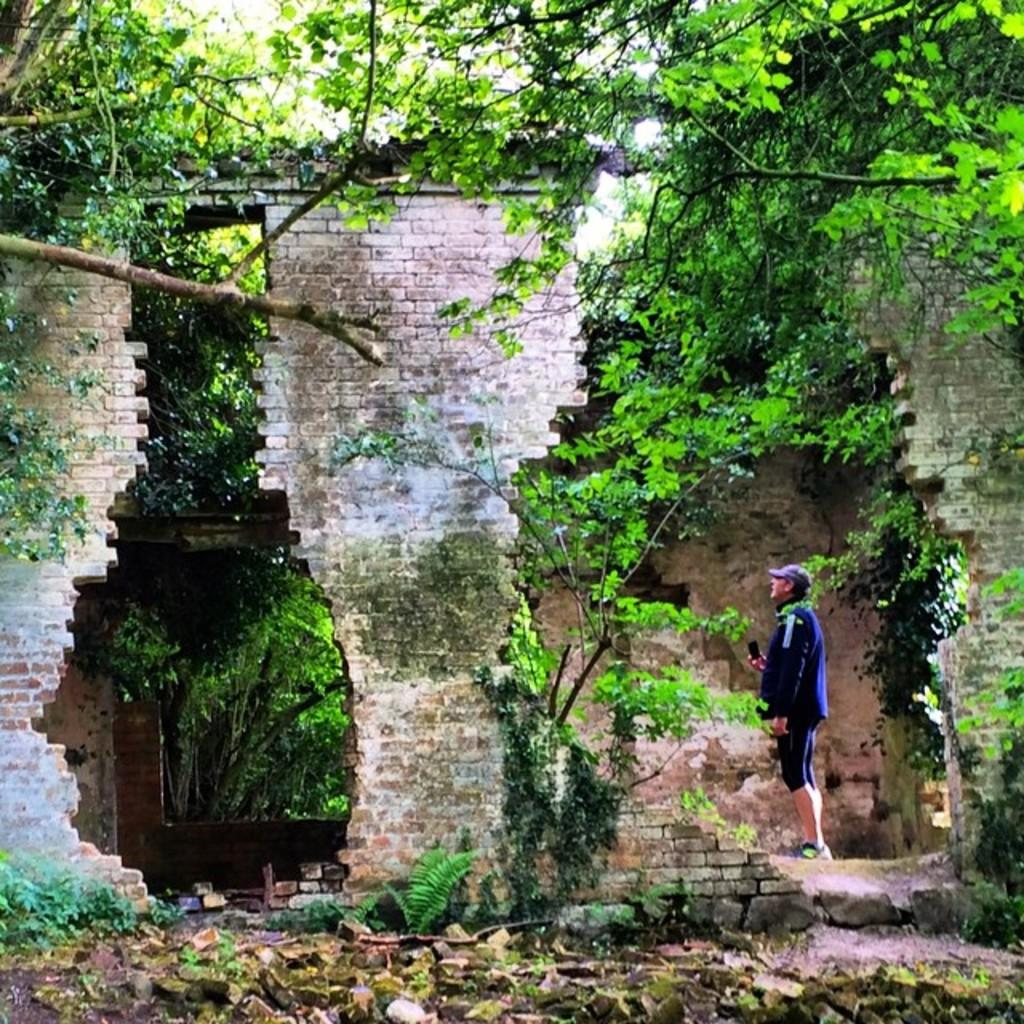What is the main subject of the image? There is a person standing in the image. Can you describe the person's clothing? The person is wearing a blue dress. What is the color of the wall in the image? The wall is in brown color. What type of vegetation can be seen in the image? There are trees in the image. What is the color of the trees? The trees are in green color. What part of the natural environment is visible in the image? The sky is visible in the image. What type of basin is hanging from the wire in the image? There is no basin or wire present in the image. What kind of loaf is being prepared by the person in the image? There is no loaf or indication of food preparation in the image. 